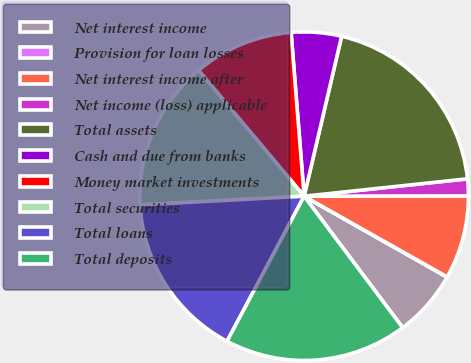Convert chart to OTSL. <chart><loc_0><loc_0><loc_500><loc_500><pie_chart><fcel>Net interest income<fcel>Provision for loan losses<fcel>Net interest income after<fcel>Net income (loss) applicable<fcel>Total assets<fcel>Cash and due from banks<fcel>Money market investments<fcel>Total securities<fcel>Total loans<fcel>Total deposits<nl><fcel>6.57%<fcel>0.02%<fcel>8.2%<fcel>1.66%<fcel>19.65%<fcel>4.93%<fcel>9.84%<fcel>14.74%<fcel>16.38%<fcel>18.01%<nl></chart> 